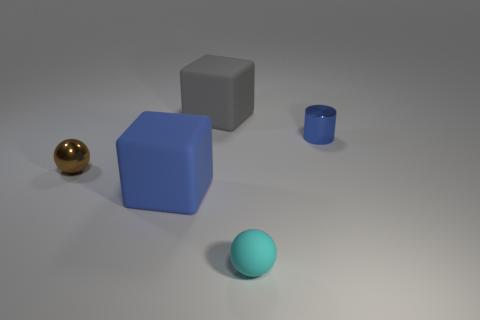Is there anything else of the same color as the tiny rubber object?
Ensure brevity in your answer.  No. How many tiny blue cubes are there?
Your answer should be compact. 0. There is a small object that is both behind the tiny cyan rubber sphere and on the left side of the small blue thing; what shape is it?
Provide a short and direct response. Sphere. There is a big thing that is in front of the tiny sphere behind the tiny cyan ball to the right of the tiny brown metal ball; what is its shape?
Your answer should be very brief. Cube. There is a thing that is both left of the small blue shiny object and behind the small brown metal object; what material is it made of?
Make the answer very short. Rubber. What number of cyan matte objects are the same size as the gray object?
Your answer should be very brief. 0. How many metallic objects are either blue blocks or objects?
Your answer should be compact. 2. What is the brown ball made of?
Offer a very short reply. Metal. How many blue rubber cubes are right of the cyan rubber sphere?
Give a very brief answer. 0. Is the material of the blue cube that is in front of the large gray matte block the same as the big gray block?
Keep it short and to the point. Yes. 